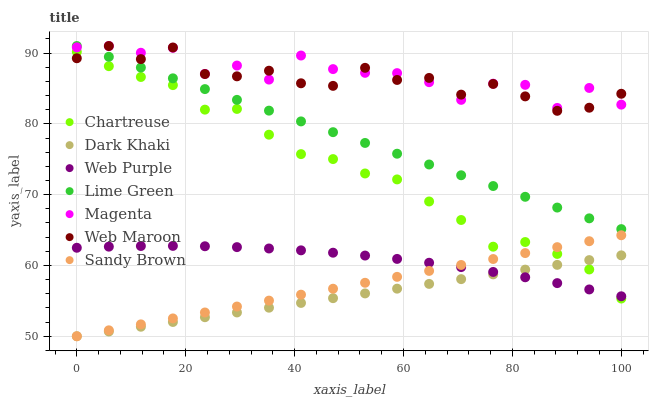Does Dark Khaki have the minimum area under the curve?
Answer yes or no. Yes. Does Magenta have the maximum area under the curve?
Answer yes or no. Yes. Does Web Maroon have the minimum area under the curve?
Answer yes or no. No. Does Web Maroon have the maximum area under the curve?
Answer yes or no. No. Is Sandy Brown the smoothest?
Answer yes or no. Yes. Is Magenta the roughest?
Answer yes or no. Yes. Is Web Maroon the smoothest?
Answer yes or no. No. Is Web Maroon the roughest?
Answer yes or no. No. Does Sandy Brown have the lowest value?
Answer yes or no. Yes. Does Web Maroon have the lowest value?
Answer yes or no. No. Does Lime Green have the highest value?
Answer yes or no. Yes. Does Web Purple have the highest value?
Answer yes or no. No. Is Chartreuse less than Magenta?
Answer yes or no. Yes. Is Lime Green greater than Web Purple?
Answer yes or no. Yes. Does Web Maroon intersect Chartreuse?
Answer yes or no. Yes. Is Web Maroon less than Chartreuse?
Answer yes or no. No. Is Web Maroon greater than Chartreuse?
Answer yes or no. No. Does Chartreuse intersect Magenta?
Answer yes or no. No. 